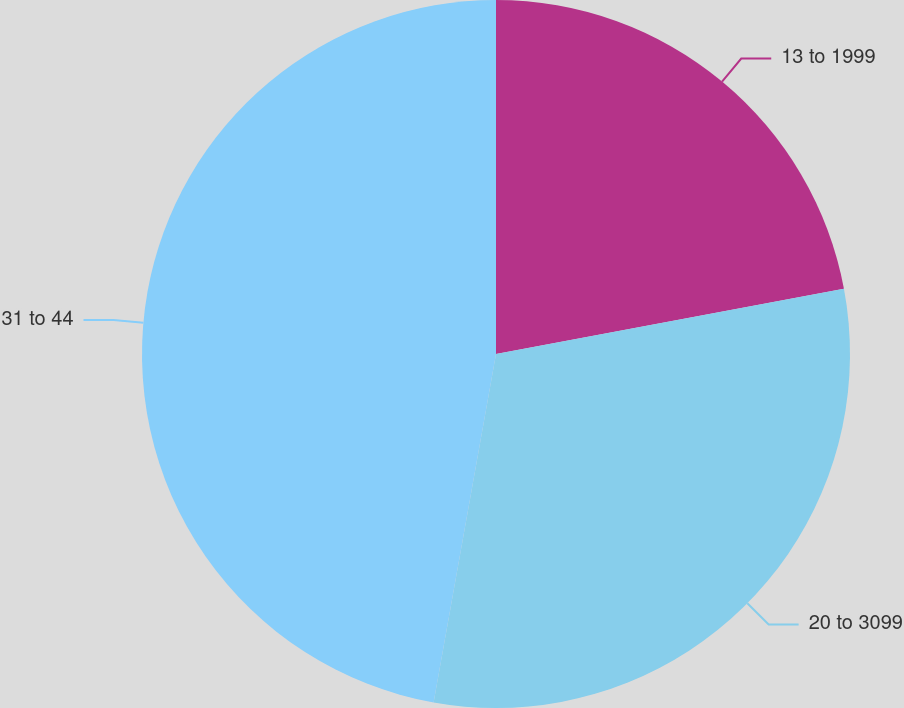<chart> <loc_0><loc_0><loc_500><loc_500><pie_chart><fcel>13 to 1999<fcel>20 to 3099<fcel>31 to 44<nl><fcel>22.05%<fcel>30.77%<fcel>47.18%<nl></chart> 